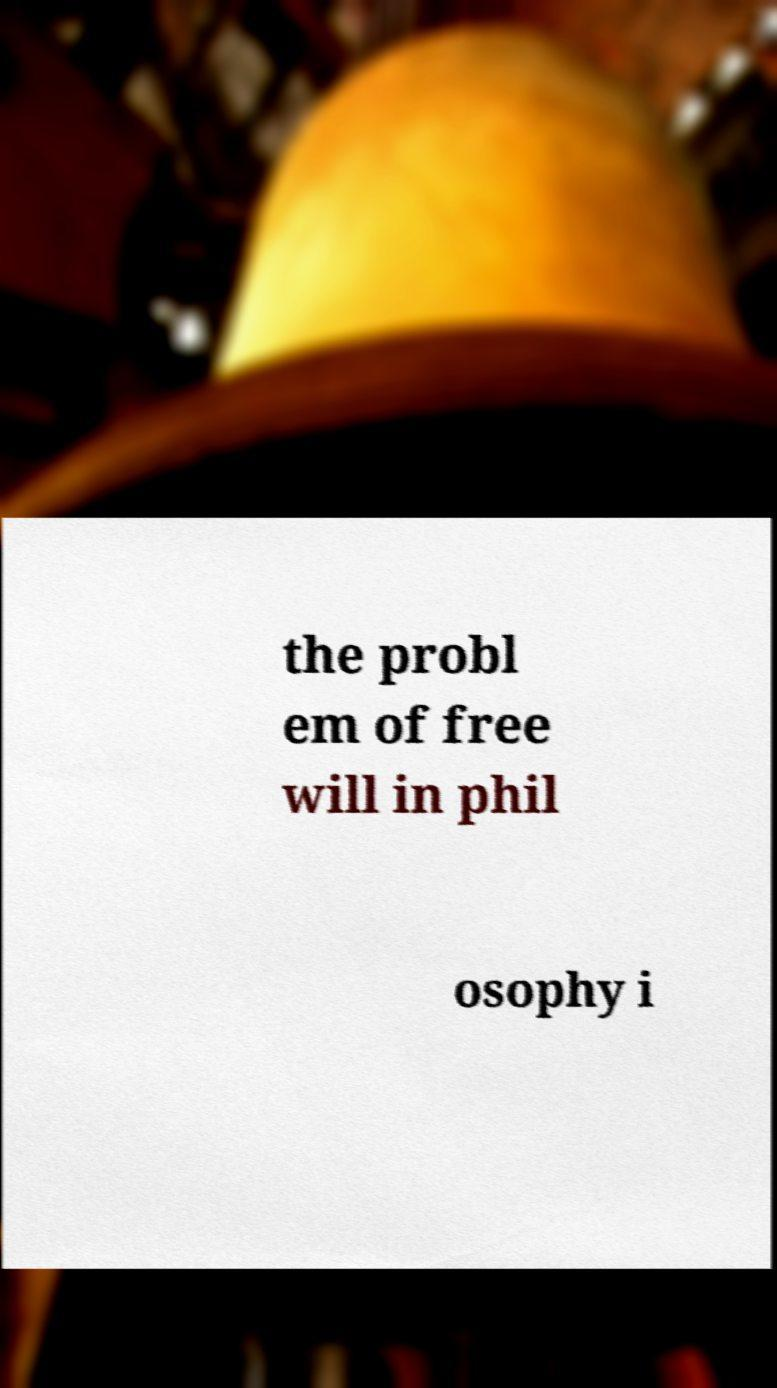I need the written content from this picture converted into text. Can you do that? the probl em of free will in phil osophy i 